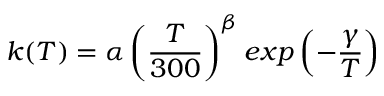<formula> <loc_0><loc_0><loc_500><loc_500>k ( T ) = \alpha \left ( \frac { T } { 3 0 0 } \right ) ^ { \beta } e x p \left ( - \frac { \gamma } { T } \right )</formula> 